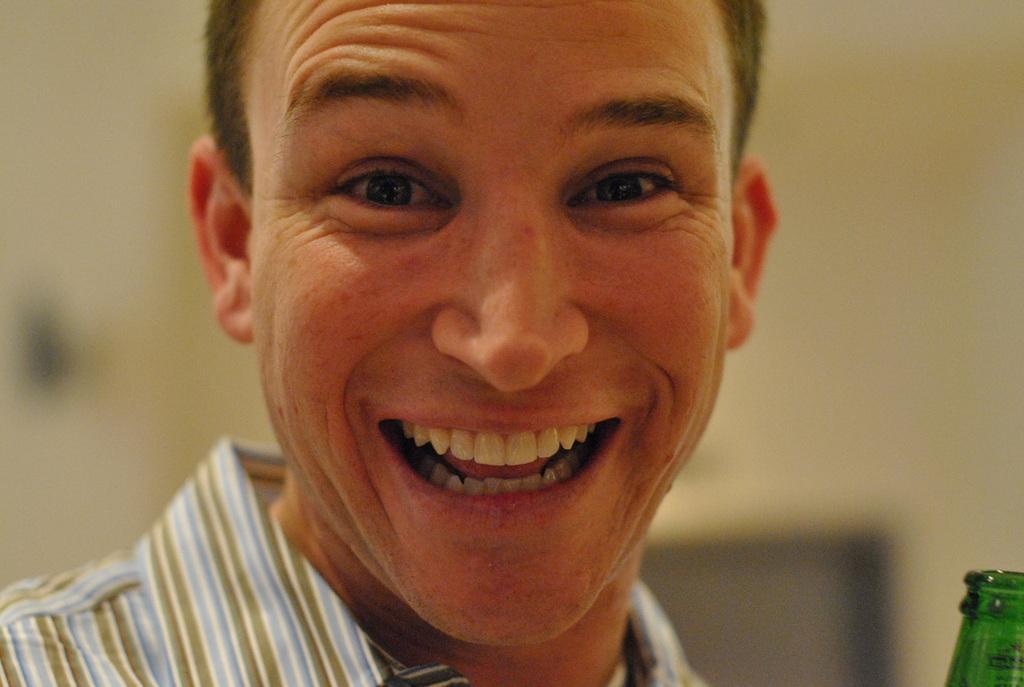Could you give a brief overview of what you see in this image? In this picture I can see there is a man, laughing and he is wearing a shirt. There is a green color bottle visible to the right side bottom of the image and the backdrop is blurred. 